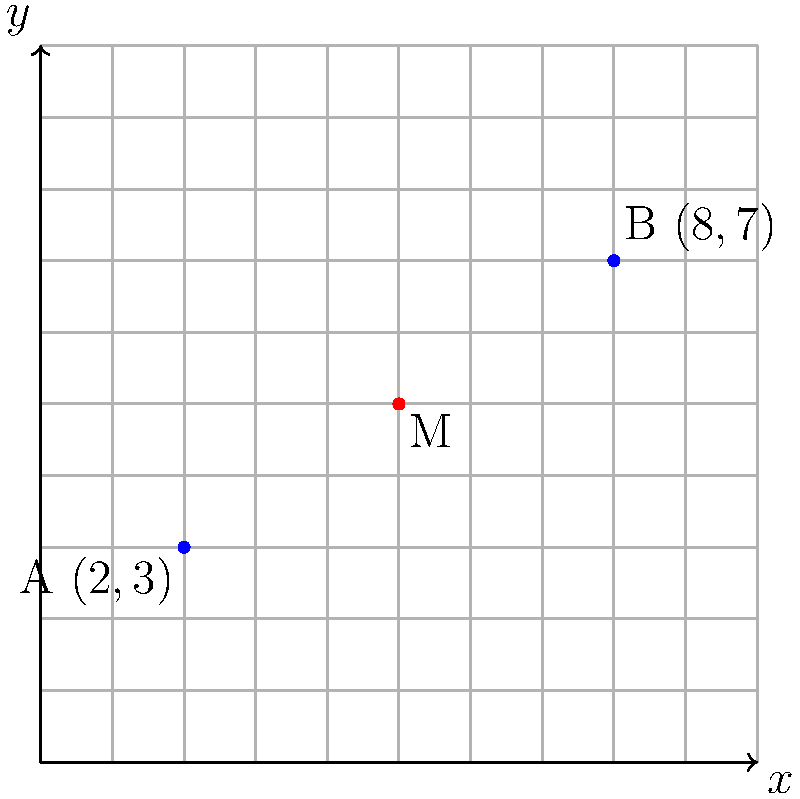As a protective mountain goat guiding a young Tahr, you need to find a safe resting spot between two water sources. Water source A is located at $(2,3)$ and water source B is at $(8,7)$ on the terrain map. What are the coordinates of the midpoint M between these two water sources? To find the midpoint between two points, we use the midpoint formula:

$$ M_x = \frac{x_1 + x_2}{2}, \quad M_y = \frac{y_1 + y_2}{2} $$

Where $(x_1, y_1)$ are the coordinates of point A, and $(x_2, y_2)$ are the coordinates of point B.

1. Identify the coordinates:
   Point A: $(2,3)$
   Point B: $(8,7)$

2. Calculate the x-coordinate of the midpoint:
   $$ M_x = \frac{2 + 8}{2} = \frac{10}{2} = 5 $$

3. Calculate the y-coordinate of the midpoint:
   $$ M_y = \frac{3 + 7}{2} = \frac{10}{2} = 5 $$

4. Combine the results:
   The midpoint M has coordinates $(5,5)$

This point represents the safest resting spot equidistant from both water sources, allowing the mountain goat to keep watch over the young Tahr while maintaining easy access to water.
Answer: $(5,5)$ 